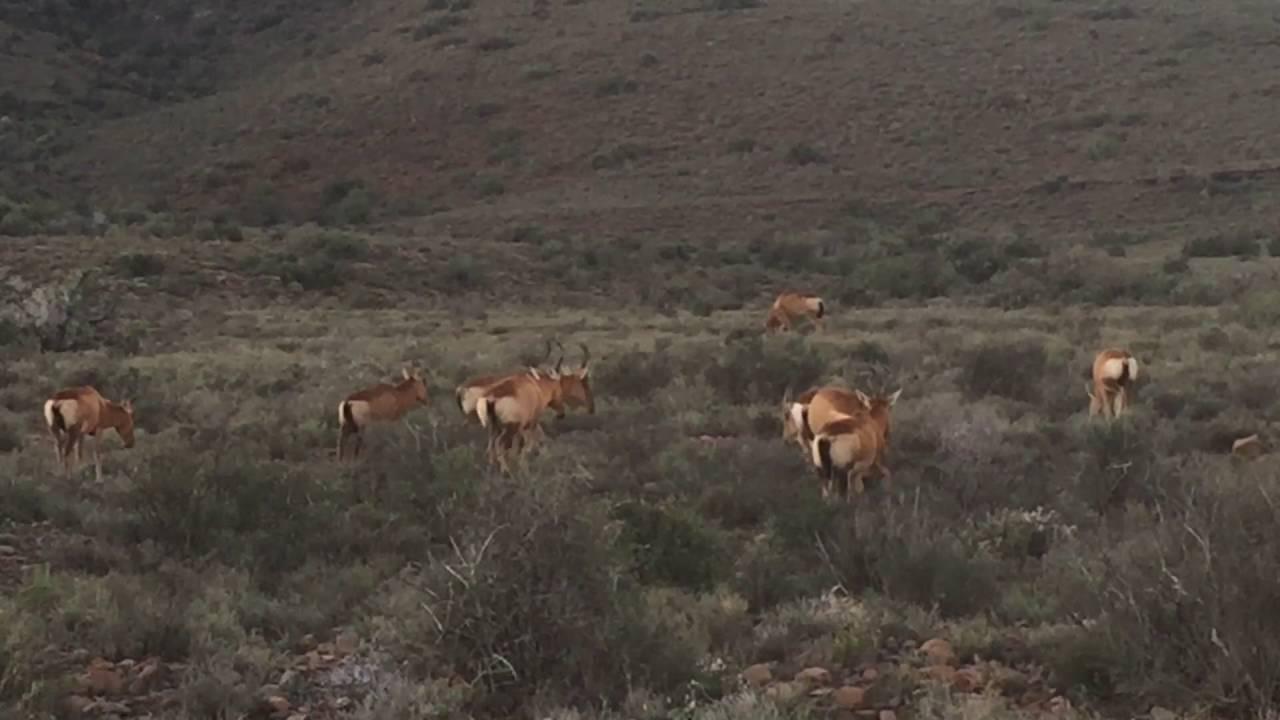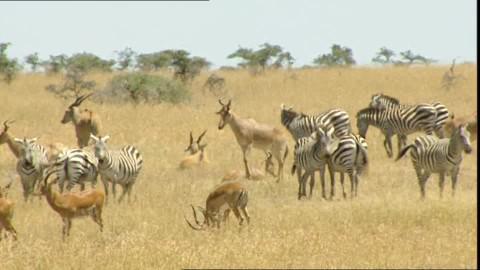The first image is the image on the left, the second image is the image on the right. For the images displayed, is the sentence "An image contains just one horned animal in a field." factually correct? Answer yes or no. No. The first image is the image on the left, the second image is the image on the right. Assess this claim about the two images: "There is only one animal in one of the images.". Correct or not? Answer yes or no. No. 